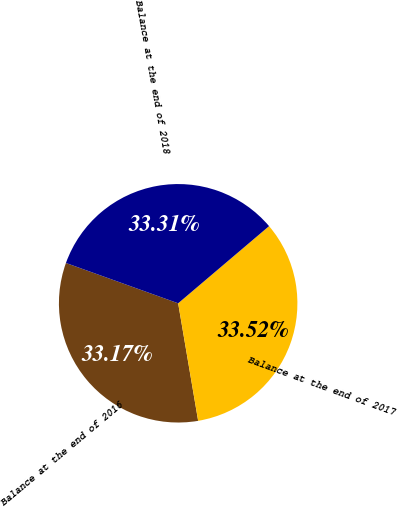Convert chart to OTSL. <chart><loc_0><loc_0><loc_500><loc_500><pie_chart><fcel>Balance at the end of 2016<fcel>Balance at the end of 2017<fcel>Balance at the end of 2018<nl><fcel>33.17%<fcel>33.52%<fcel>33.31%<nl></chart> 